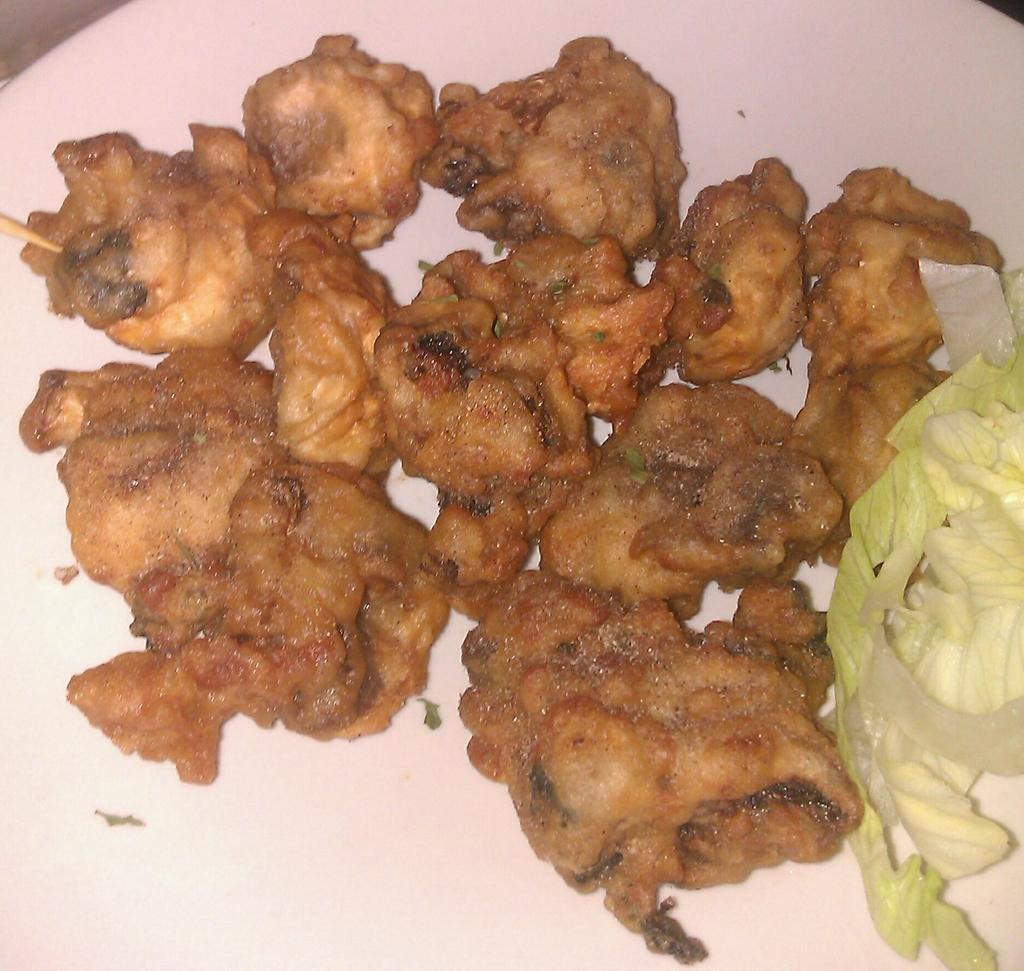What can be seen in the image? There are food items in the image. How are the food items arranged or presented? The food items are in a plate. What type of hammer is being used to prepare the food in the image? There is no hammer present in the image, and no food preparation is shown. 